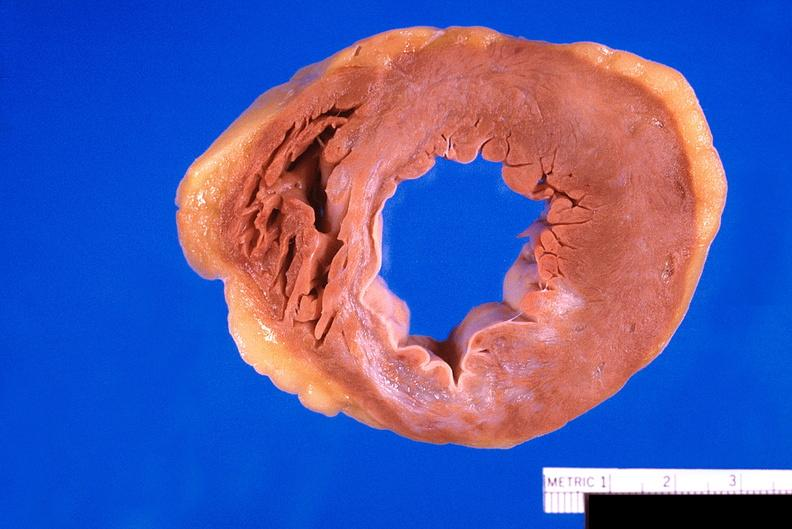what does this image show?
Answer the question using a single word or phrase. Heart 